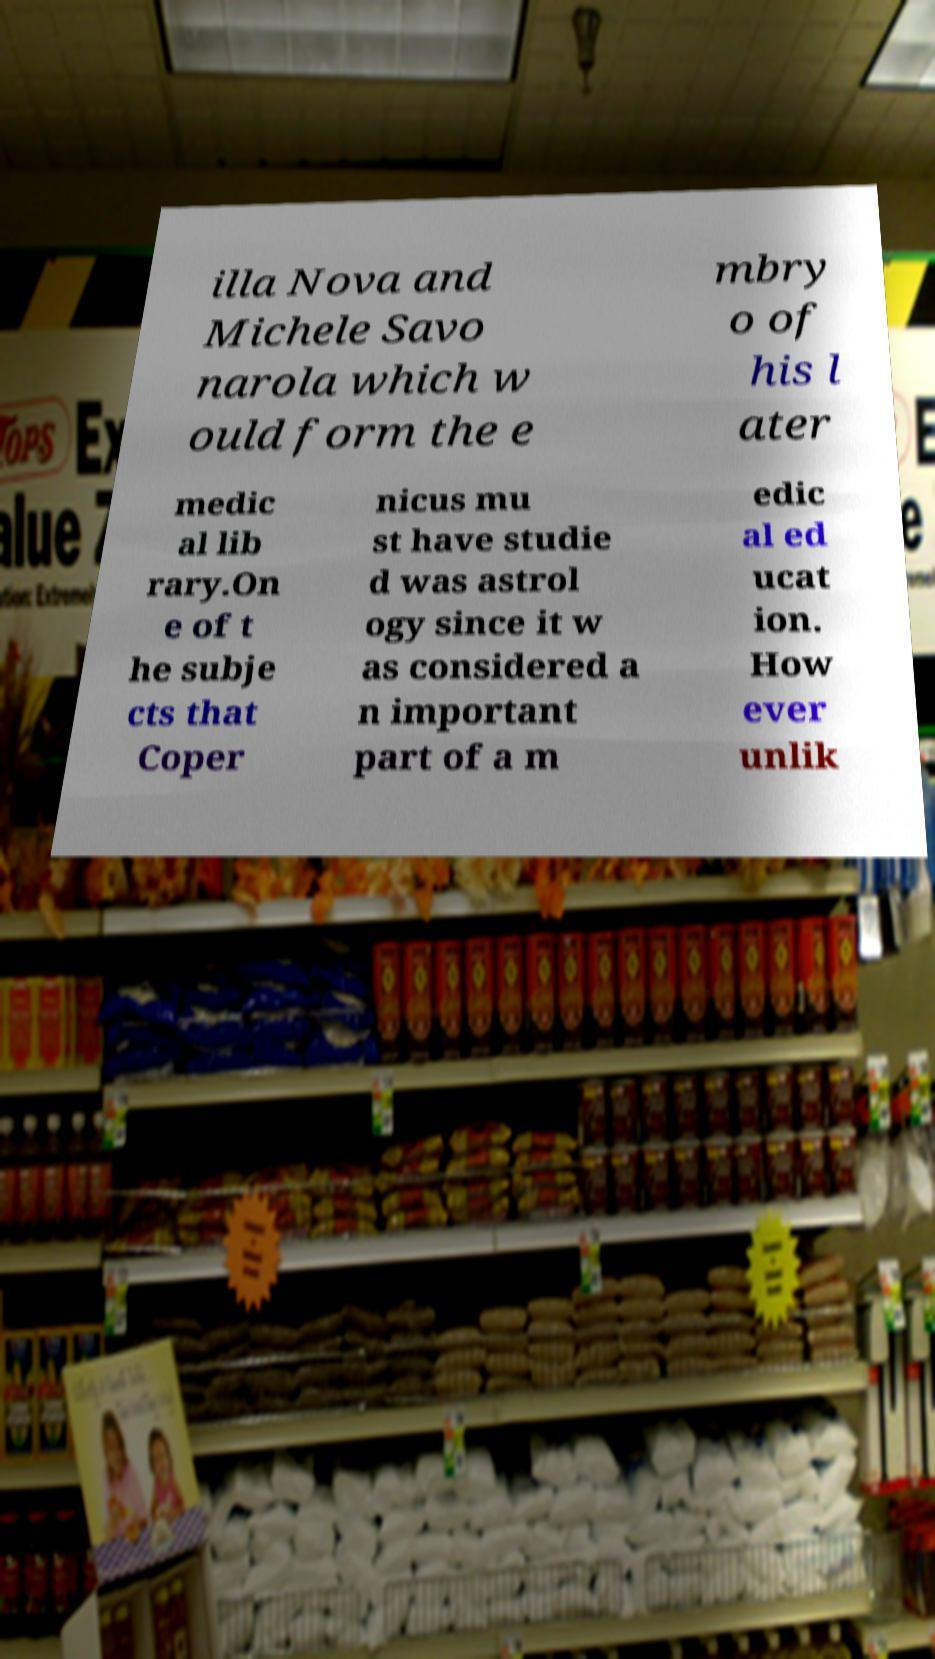Please identify and transcribe the text found in this image. illa Nova and Michele Savo narola which w ould form the e mbry o of his l ater medic al lib rary.On e of t he subje cts that Coper nicus mu st have studie d was astrol ogy since it w as considered a n important part of a m edic al ed ucat ion. How ever unlik 